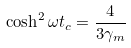Convert formula to latex. <formula><loc_0><loc_0><loc_500><loc_500>\cosh ^ { 2 } \omega t _ { c } = \frac { 4 } { 3 \gamma _ { m } }</formula> 